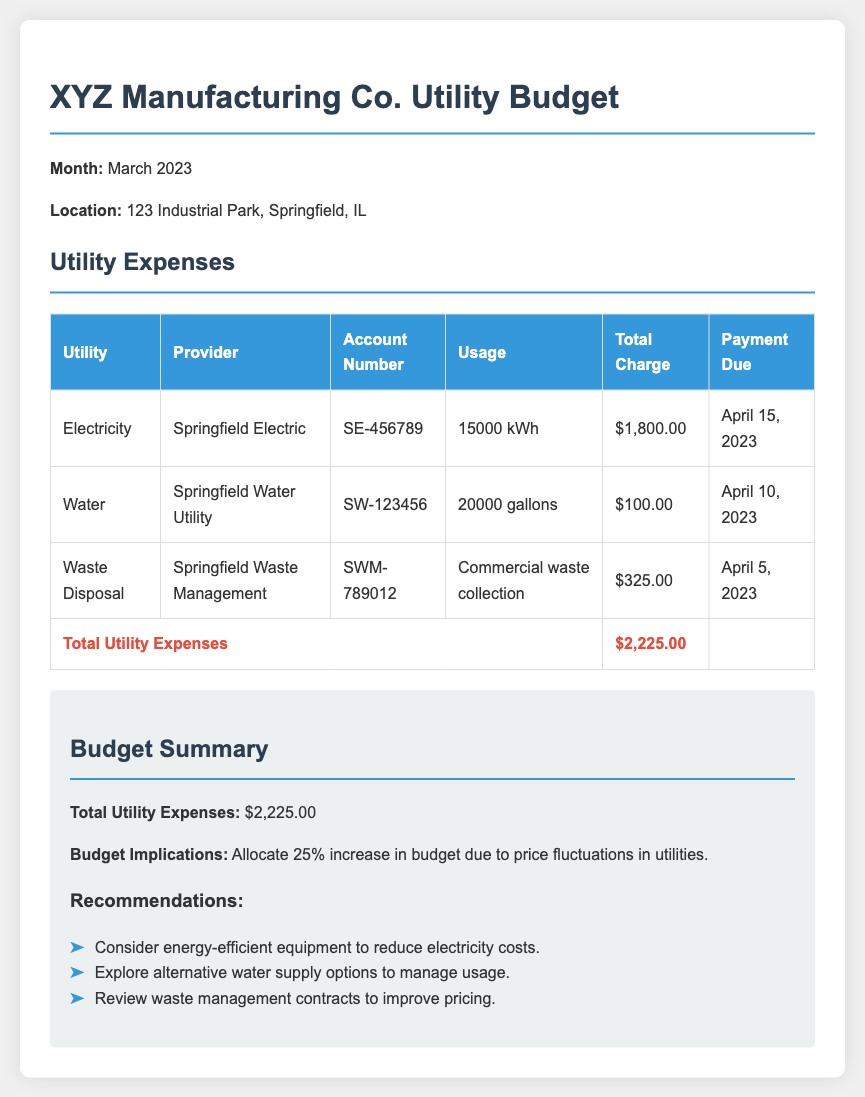What is the total charge for electricity? The total charge for electricity is stated in the document under the Electricity row, which is $1,800.00.
Answer: $1,800.00 What is the usage of water? The usage of water for the facility is mentioned as 20,000 gallons in the Water row.
Answer: 20,000 gallons When is the payment due for waste disposal? The payment due date for waste disposal is provided in the Waste Disposal row, which is April 5, 2023.
Answer: April 5, 2023 What percentage increase is recommended for the budget? Budget implications note a 25% increase due to price fluctuations in utilities, providing the reasoning for the recommended budget change.
Answer: 25% What is the total utility expenses? The total utility expenses calculate all listed charges, which results in $2,225.00 in the summary section at the end of the document.
Answer: $2,225.00 What is the provider of the electricity service? The document lists Springfield Electric as the electricity provider in the Electricity row.
Answer: Springfield Electric How many gallons of water were used? The document specifies that the usage of water was 20,000 gallons, stated in the Water row.
Answer: 20,000 gallons What recommendation is given for electricity costs? The document suggests considering energy-efficient equipment to reduce electricity costs as a specific recommendation in the recommendations section.
Answer: Energy-efficient equipment 